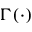<formula> <loc_0><loc_0><loc_500><loc_500>\Gamma ( \cdot )</formula> 